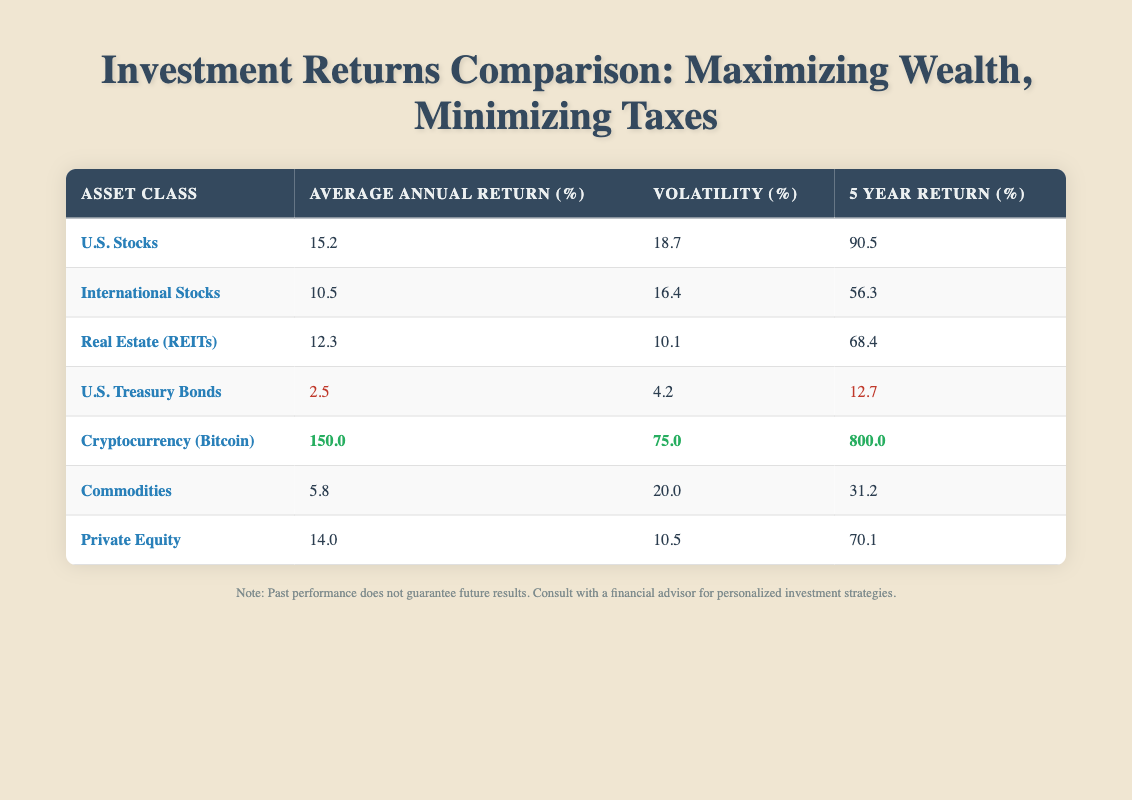What is the 5-year return for U.S. Stocks? You can find the 5-year return for U.S. Stocks by looking at the row where the asset class is "U.S. Stocks". The 5-year return value listed there is 90.5%.
Answer: 90.5% Which asset class has the highest volatility? To determine which asset class has the highest volatility, compare the volatility values listed in the table. Cryptocurrency has the highest volatility at 75.0%.
Answer: Cryptocurrency (Bitcoin) What is the average of the 5-year returns for Real Estate (REITs) and Private Equity? First, find the 5-year returns for Real Estate (REITs), which is 68.4%, and for Private Equity, which is 70.1%. Next, sum these two returns: 68.4 + 70.1 = 138.5. Finally, divide by 2 to find the average: 138.5 / 2 = 69.25%.
Answer: 69.25% Is it true that International Stocks have a higher average annual return than U.S. Treasury Bonds? Look at the average annual returns for both asset classes. International Stocks have an average annual return of 10.5%, while U.S. Treasury Bonds have a return of 2.5%. Therefore, it's true that International Stocks have a higher average annual return.
Answer: Yes What is the difference in 5-year returns between Cryptocurrency (Bitcoin) and U.S. Treasury Bonds? Start by locating the 5-year return for Cryptocurrency (800.0%) and for U.S. Treasury Bonds (12.7%). Now, calculate the difference: 800.0 - 12.7 = 787.3%.
Answer: 787.3% 